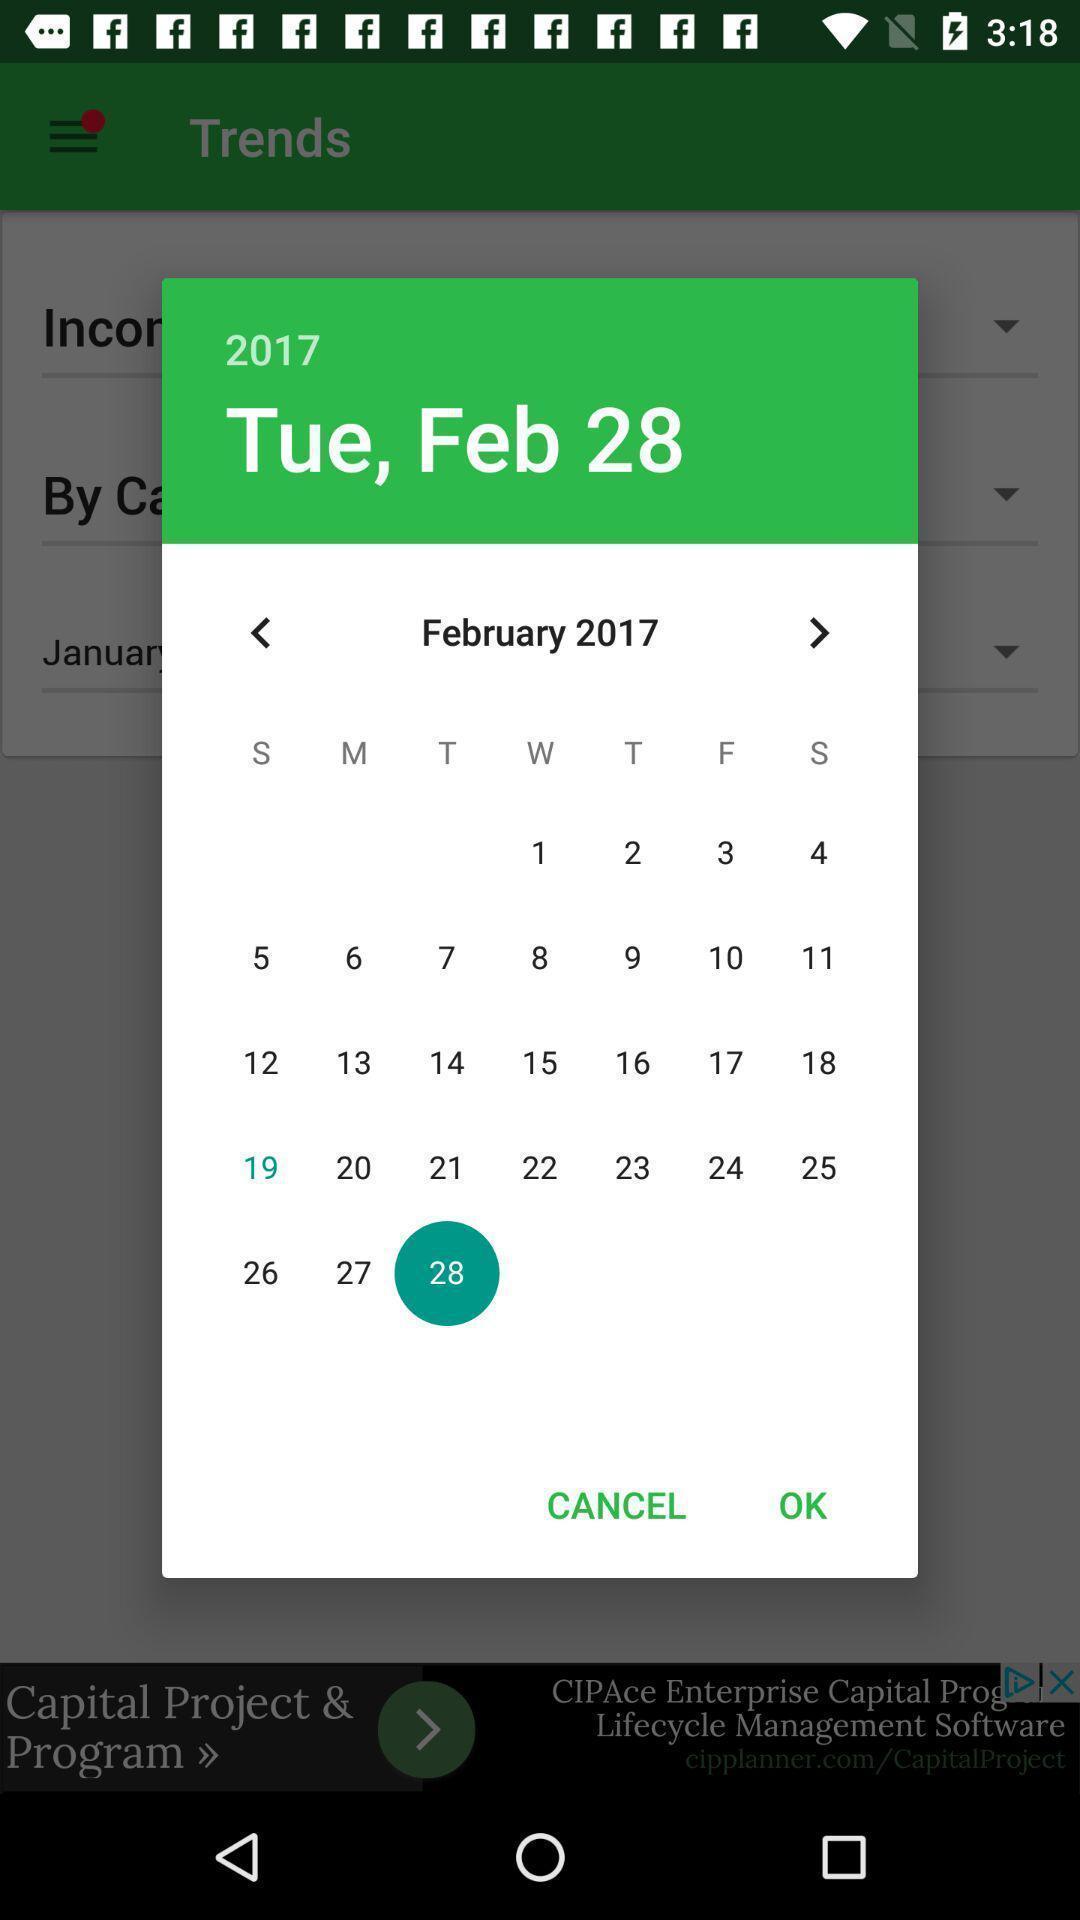Give me a narrative description of this picture. Pop-up showing a particular month in a calender. 